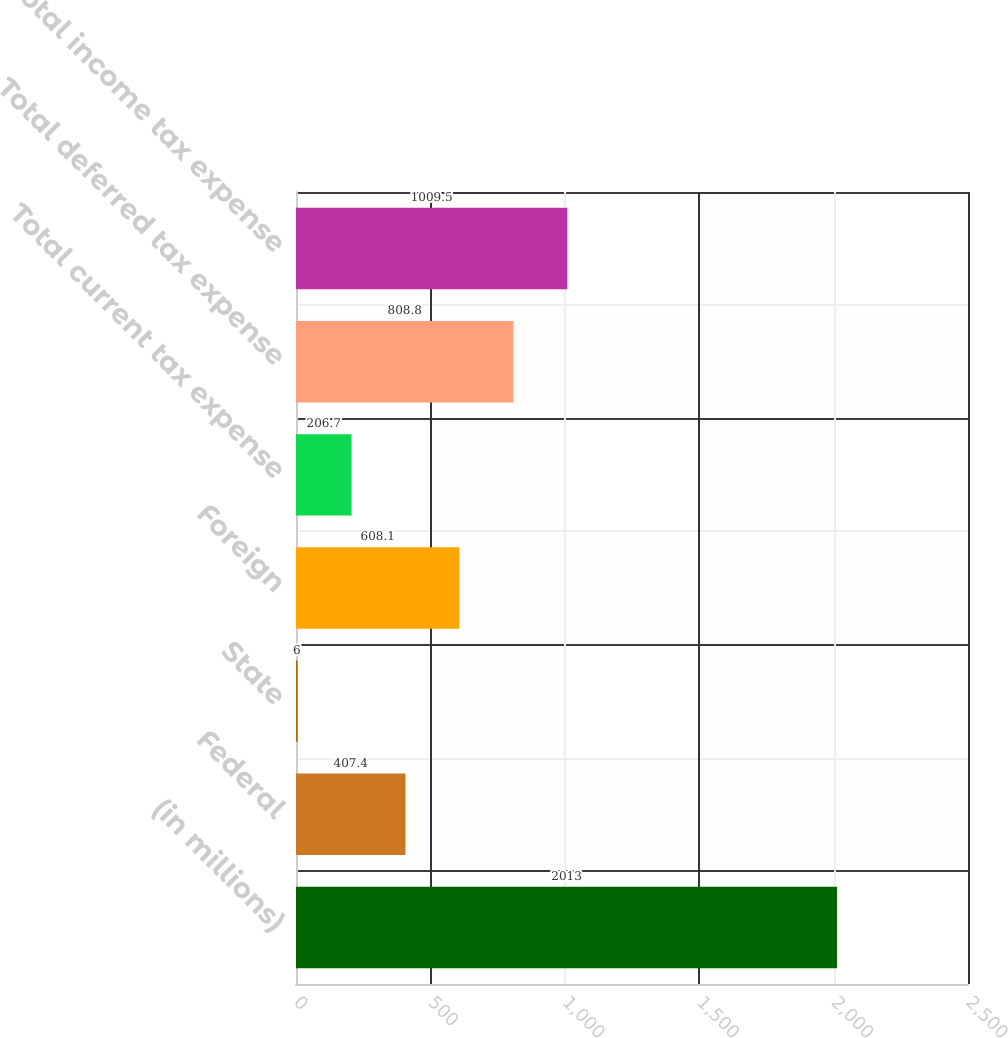<chart> <loc_0><loc_0><loc_500><loc_500><bar_chart><fcel>(in millions)<fcel>Federal<fcel>State<fcel>Foreign<fcel>Total current tax expense<fcel>Total deferred tax expense<fcel>Total income tax expense<nl><fcel>2013<fcel>407.4<fcel>6<fcel>608.1<fcel>206.7<fcel>808.8<fcel>1009.5<nl></chart> 